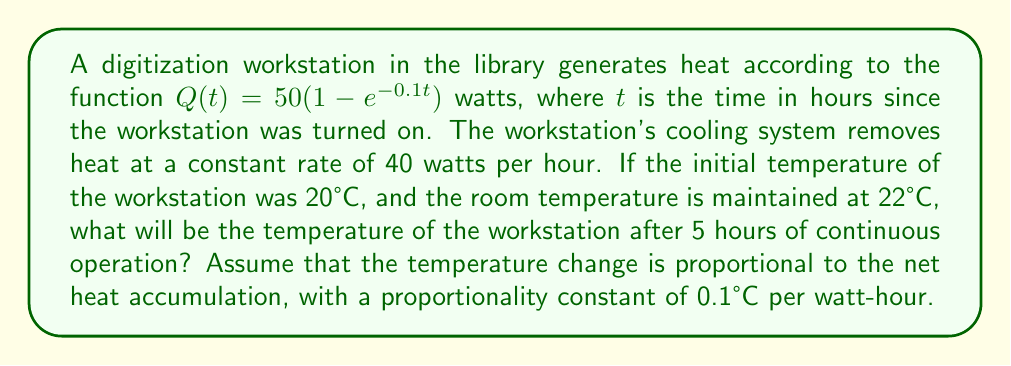Can you answer this question? Let's approach this step-by-step:

1) First, we need to find the net heat accumulation over 5 hours.

2) Heat generated after 5 hours:
   $$Q(5) = 50(1 - e^{-0.1(5)}) = 50(1 - e^{-0.5}) \approx 39.35 \text{ watts}$$

3) Heat removed in 5 hours:
   $$40 \text{ watts/hour} \times 5 \text{ hours} = 200 \text{ watts}$$

4) Net heat accumulation over 5 hours:
   $$\int_0^5 [Q(t) - 40] dt = \int_0^5 [50(1 - e^{-0.1t}) - 40] dt$$
   $$= [50t + 500e^{-0.1t} - 40t]_0^5$$
   $$= (250 + 500e^{-0.5} - 200) - (0 + 500 - 0)$$
   $$= 50 + 500e^{-0.5} - 500 \approx -146.51 \text{ watt-hours}$$

5) Temperature change:
   $$\Delta T = 0.1 \times (-146.51) \approx -14.65°C$$

6) Final temperature:
   $$T_{\text{final}} = 20°C + (-14.65°C) = 5.35°C$$

7) However, the room temperature is maintained at 22°C, so the workstation cannot cool below this temperature.

Therefore, the final temperature of the workstation after 5 hours will be 22°C.
Answer: 22°C 